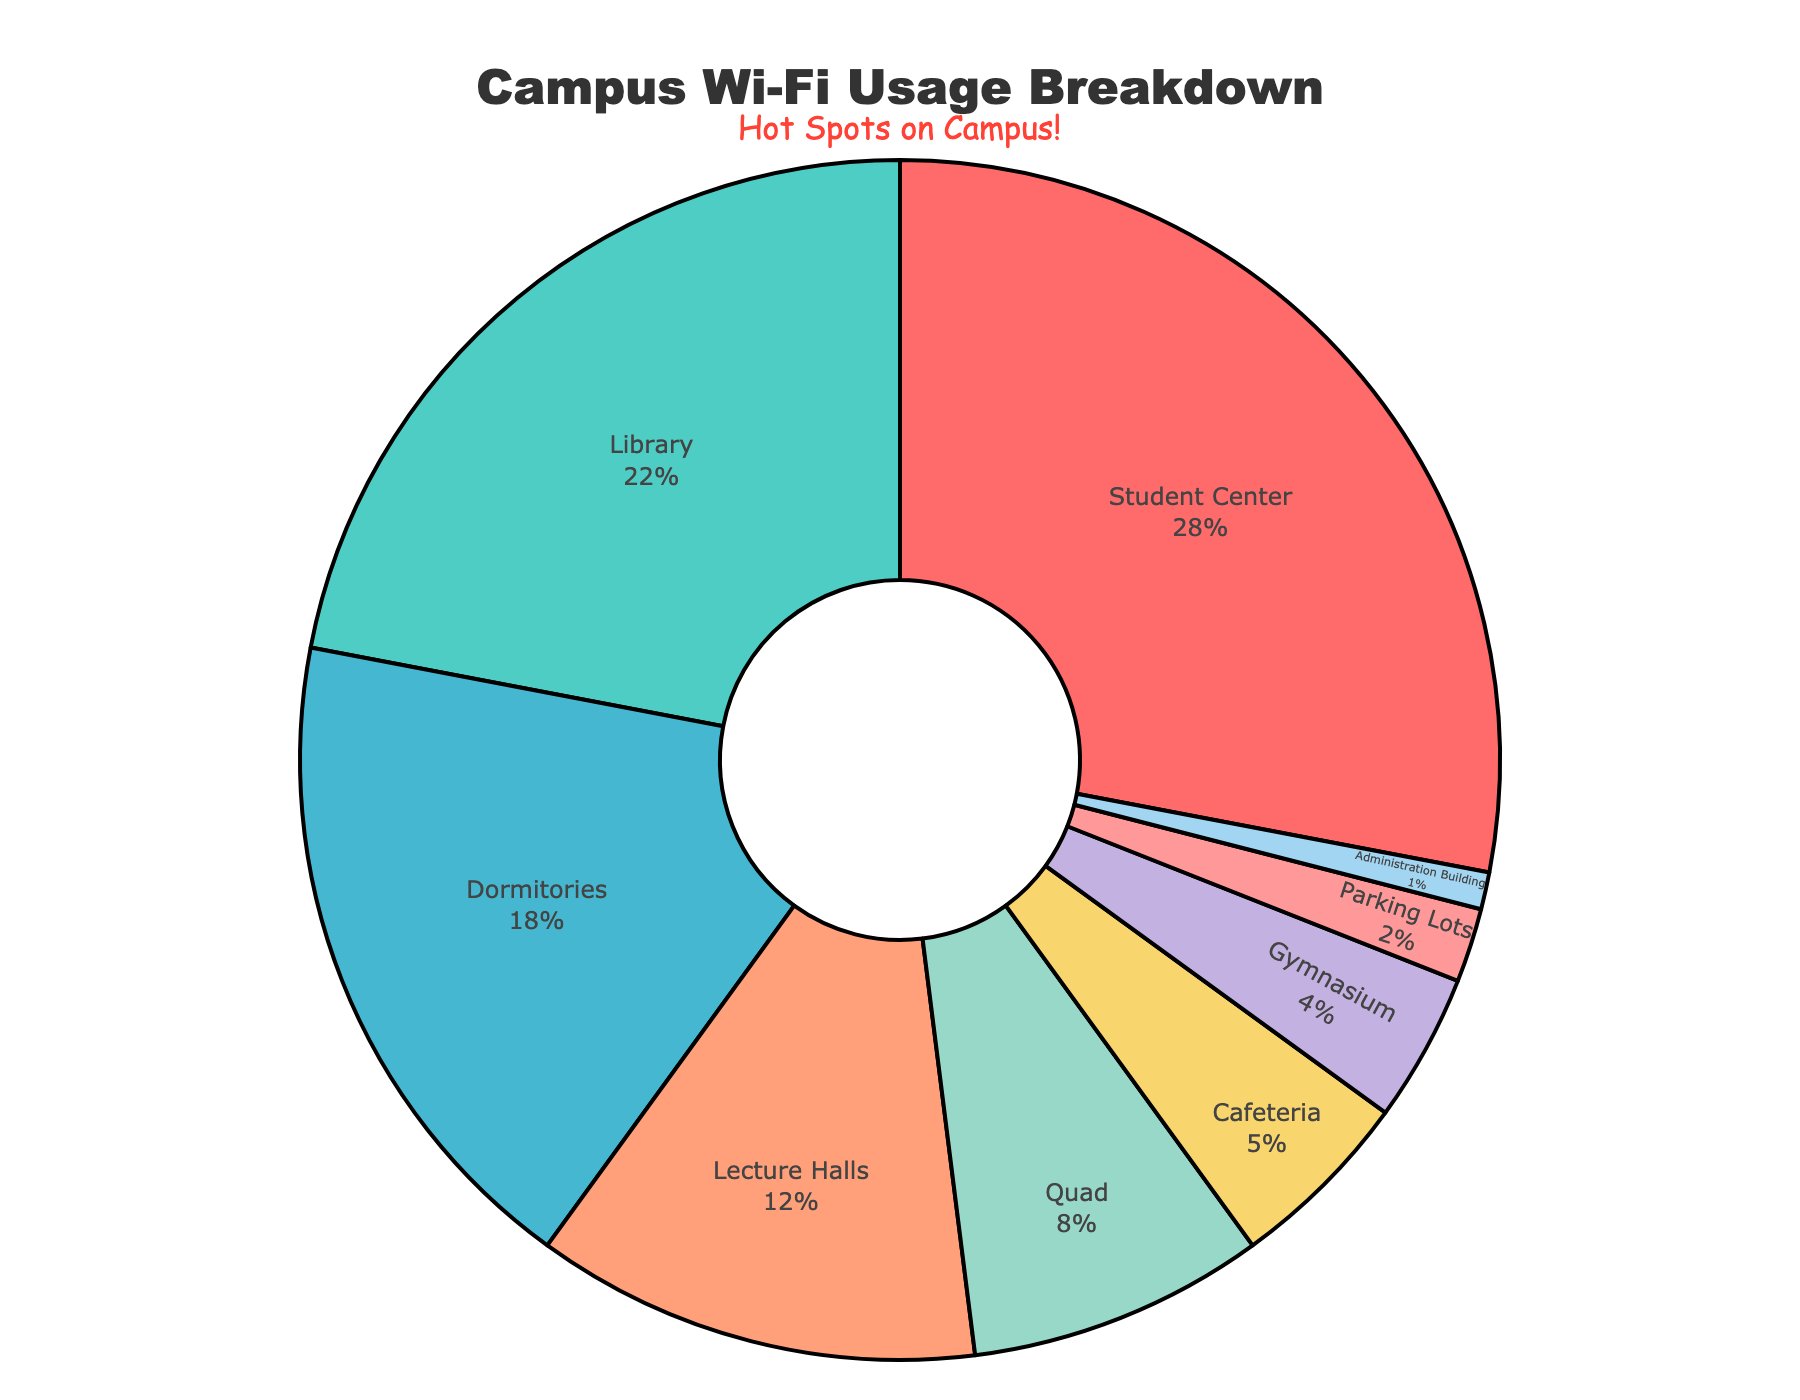What's the total percentage of Wi-Fi usage in the Student Center, Library, and Dormitories combined? Add the percentages of Wi-Fi usage for Student Center (28%), Library (22%), and Dormitories (18%): 28 + 22 + 18 = 68.
Answer: 68 Which location has the highest Wi-Fi usage? Identify the segment with the largest percentage. The Student Center has the highest usage at 28%.
Answer: Student Center How does the Wi-Fi usage in the Gymnasium compare to that in the Cafeteria? Gymnasium's usage is 4% and Cafeteria's usage is 5%. Compare the two values: 4% < 5%.
Answer: Less What is the difference in Wi-Fi usage between Lecture Halls and Parking Lots? Calculate the Wi-Fi usage difference between Lecture Halls (12%) and Parking Lots (2%): 12 - 2 = 10.
Answer: 10 What's the average Wi-Fi usage across all the listed locations? Sum all percentages and divide by the number of locations (9): (28 + 22 + 18 + 12 + 8 + 5 + 4 + 2 + 1) / 9 = 100 / 9 ≈ 11.11.
Answer: ≈ 11.11 Which two locations combined account for over half of the total Wi-Fi usage? Check combinations: Student Center (28%) + Library (22%) = 50%; Student Center (28%) + Dormitories (18%) = 46%; Library (22%) + Dormitories (18%) = 40%. The combination over half is Student Center (28%) + Library (22%) = 50%.
Answer: Student Center and Library If the Wi-Fi usage in the Quad doubled, what would its new percentage be? Double the current percentage for the Quad (8%): 8 * 2 = 16.
Answer: 16 How much more Wi-Fi is used in the Library compared to the Administration Building? Subtract Administration Building's percentage (1%) from Library's percentage (22%): 22 - 1 = 21.
Answer: 21 Which color represents the Wi-Fi usage in the Quad, and what is its usage percentage? Identify the color for Quad and its corresponding percentage segment: Quad is 8% and is represented by a specific color.
Answer: 8% and associated color (dependent on Figure) If the Wi-Fi usage in Lecture Halls increased by 4%, what would its new usage percentage be? Add the increase (4%) to the current usage in Lecture Halls (12%): 12 + 4 = 16.
Answer: 16 